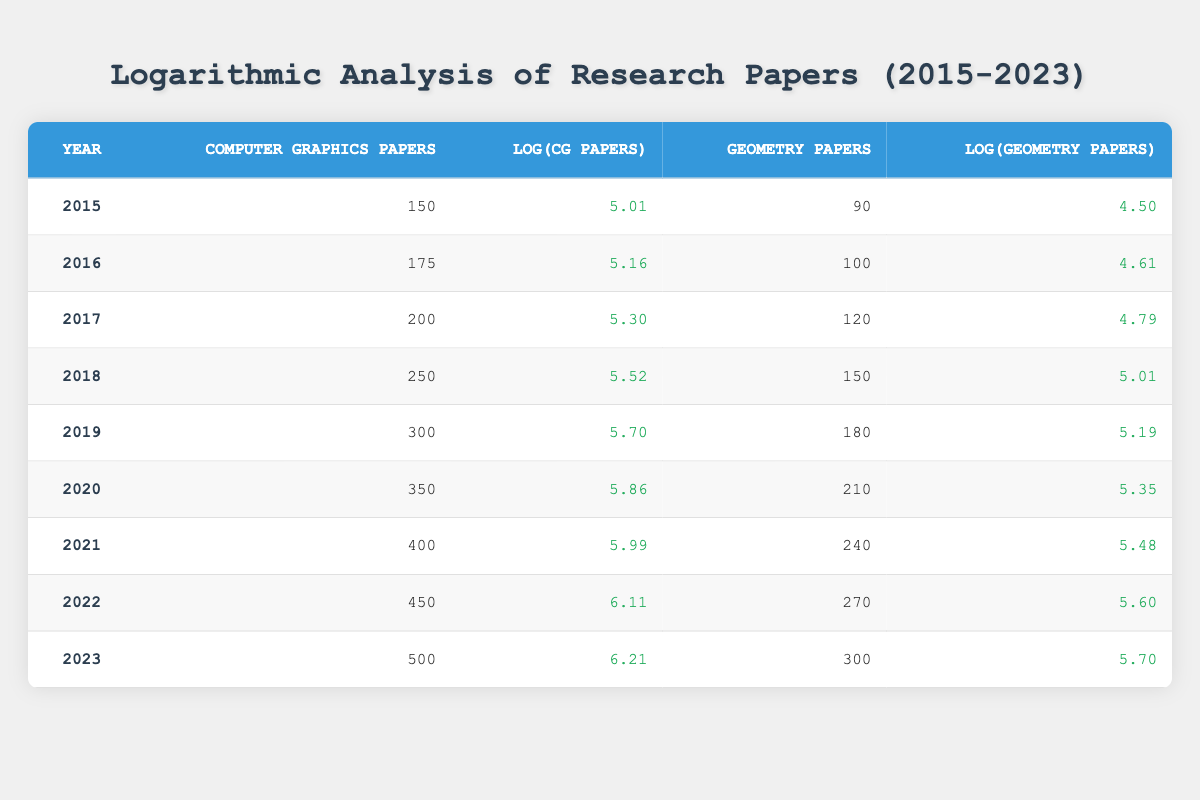What was the total number of Computer Graphics Papers published from 2015 to 2023? To find the total, we add the number of Computer Graphics Papers for each year: 150 + 175 + 200 + 250 + 300 + 350 + 400 + 450 + 500 = 2375
Answer: 2375 What is the highest number of Geometry Papers published in a single year? By inspecting the Geometry Papers column, the highest value is 300 in the year 2023
Answer: 300 In which year did the number of Computer Graphics Papers first exceed 400? Looking through the table, Computer Graphics Papers exceeded 400 in the year 2021, as 400 is the first value above 400 following the years before it
Answer: 2021 What was the average number of Geometry Papers published from 2015 to 2023? To calculate the average, sum Geometry Papers: 90 + 100 + 120 + 150 + 180 + 210 + 240 + 270 + 300 = 1620. There are 9 years, so the average is 1620 / 9 = 180
Answer: 180 Did more Computer Graphics Papers or Geometry Papers get published in 2022? In 2022, 450 Computer Graphics Papers and 270 Geometry Papers were published. Since 450 is greater than 270, more Computer Graphics Papers were published
Answer: Yes What is the difference in the number of Geometric Papers published between 2015 and 2023? The number of Geometry Papers in 2015 is 90 and in 2023 is 300. The difference is 300 - 90 = 210
Answer: 210 Which year saw the highest growth in Computer Graphics Papers compared to the previous year? Calculate the differences: 175-150 = 25 (2016), 200-175 = 25 (2017), 250-200 = 50 (2018), 300-250 = 50 (2019), 350-300 = 50 (2020), 400-350 = 50 (2021), 450-400 = 50 (2022), 500-450 = 50 (2023). The highest growth was in 2018 with an increase of 50
Answer: 50 Is it true that the number of Computer Graphics Papers increased every year from 2015 to 2023? Looking at the data from 2015 to 2023, each year's value for Computer Graphics Papers is greater than the previous year's value, confirming the increase
Answer: Yes What was the logarithmic value of Computer Graphics Papers in 2020 and how does it compare to that of 2015? The log value for 2020 is 5.86 and for 2015 it is 5.01. Comparing them, 5.86 is greater than 5.01, showing a notable increase
Answer: 5.86 is greater than 5.01 